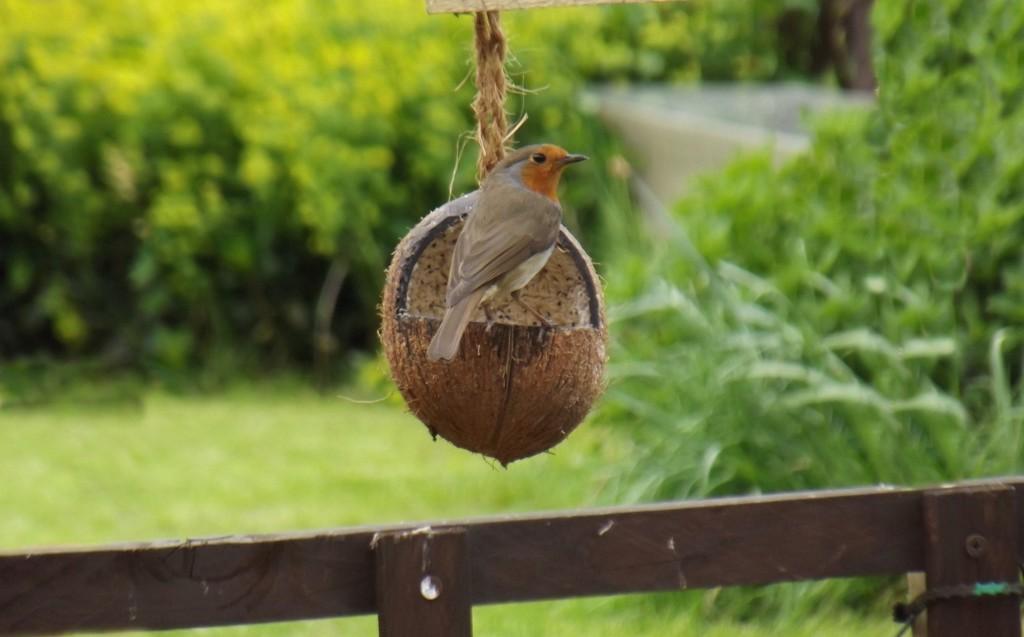Please provide a concise description of this image. In the image there is a bird standing on coconut shell which tied to a rope, below it there is a wooden fence and in the background there plants on a grassland. 